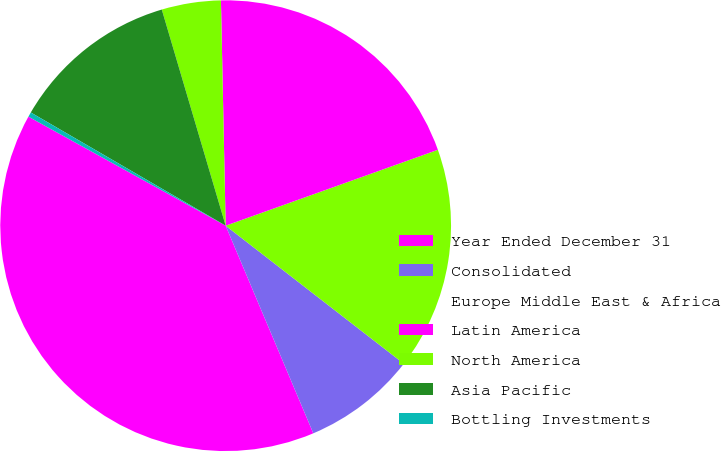Convert chart to OTSL. <chart><loc_0><loc_0><loc_500><loc_500><pie_chart><fcel>Year Ended December 31<fcel>Consolidated<fcel>Europe Middle East & Africa<fcel>Latin America<fcel>North America<fcel>Asia Pacific<fcel>Bottling Investments<nl><fcel>39.4%<fcel>8.15%<fcel>15.96%<fcel>19.87%<fcel>4.24%<fcel>12.05%<fcel>0.34%<nl></chart> 